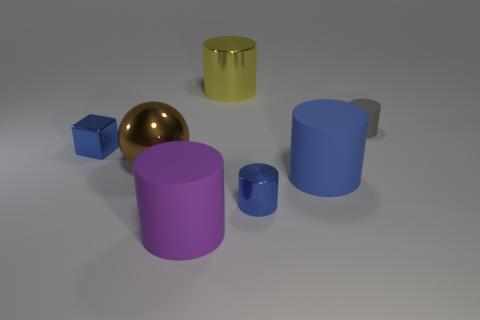Subtract all small matte cylinders. How many cylinders are left? 4 Subtract all yellow cylinders. How many cylinders are left? 4 Subtract all green cylinders. Subtract all brown blocks. How many cylinders are left? 5 Subtract all balls. How many objects are left? 6 Add 3 big blue rubber cylinders. How many objects exist? 10 Subtract all yellow cylinders. Subtract all yellow metallic objects. How many objects are left? 5 Add 6 metallic cubes. How many metallic cubes are left? 7 Add 2 big red matte cylinders. How many big red matte cylinders exist? 2 Subtract 0 yellow balls. How many objects are left? 7 